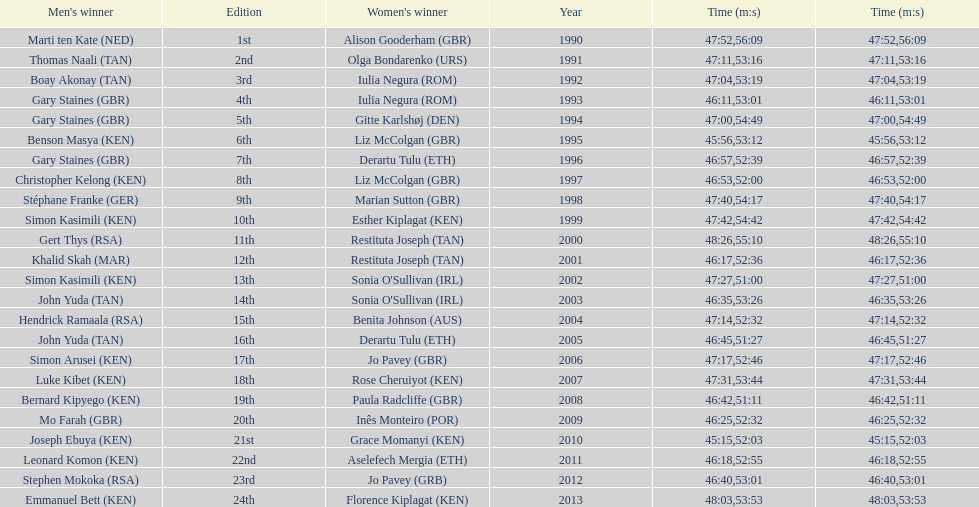The other women's winner with the same finish time as jo pavey in 2012 Iulia Negura. 